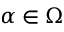<formula> <loc_0><loc_0><loc_500><loc_500>\alpha \in \Omega</formula> 